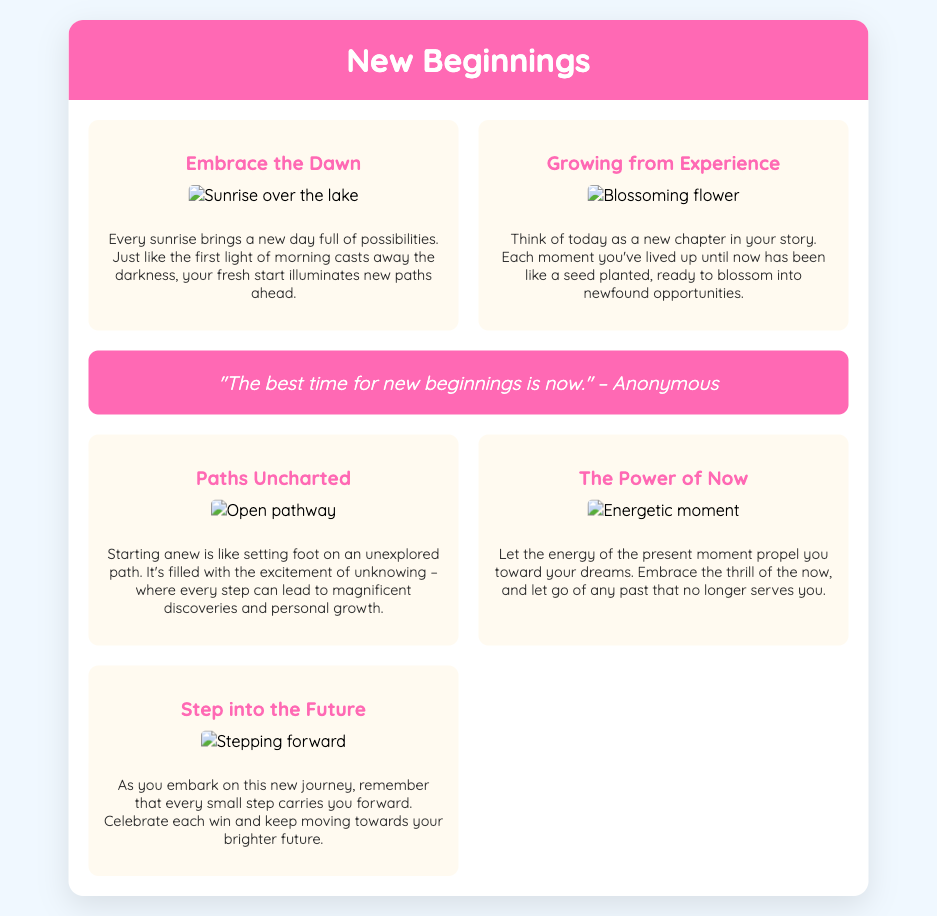What is the title of the card? The title of the card is displayed prominently at the top of the document.
Answer: New Beginnings How many sections are there in the card content? The card content consists of multiple sections representing different themes, counted in the document.
Answer: 5 What is the theme of the first section? The first section focuses on the morning light and its symbolism for fresh starts.
Answer: Embrace the Dawn What quote is included in the card? The quote is found in the special quote section of the card, providing motivation.
Answer: "The best time for new beginnings is now." What imagery is associated with the theme of personal growth? The imagery of blooming or blossoming is related to growth and experience.
Answer: Blossoming flower What is emphasized in the section "The Power of Now"? This section discusses living in the moment and its benefits for future aspirations.
Answer: Energy of the present moment Which section suggests celebrating small victories? This section encourages recognition of progress in the journey ahead.
Answer: Step into the Future What color is used for the card header? The card header features a specific color that stands out and sets the tone.
Answer: Pink What type of imagery is seen in the section "Paths Uncharted"? The imagery reflects exploration and discovery related to starting anew.
Answer: Open pathway 